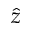Convert formula to latex. <formula><loc_0><loc_0><loc_500><loc_500>\hat { z }</formula> 